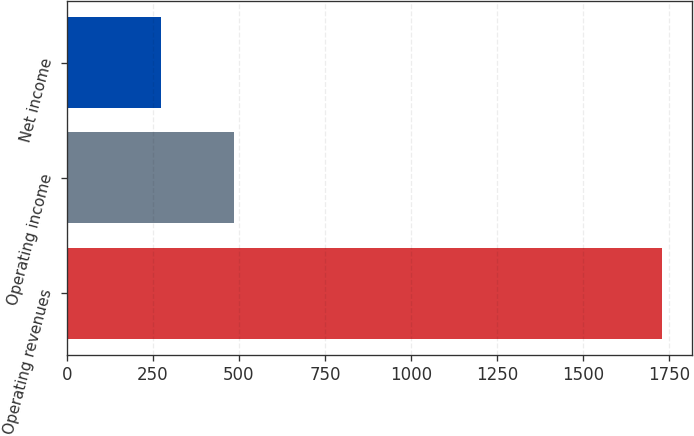Convert chart to OTSL. <chart><loc_0><loc_0><loc_500><loc_500><bar_chart><fcel>Operating revenues<fcel>Operating income<fcel>Net income<nl><fcel>1729<fcel>485<fcel>273<nl></chart> 